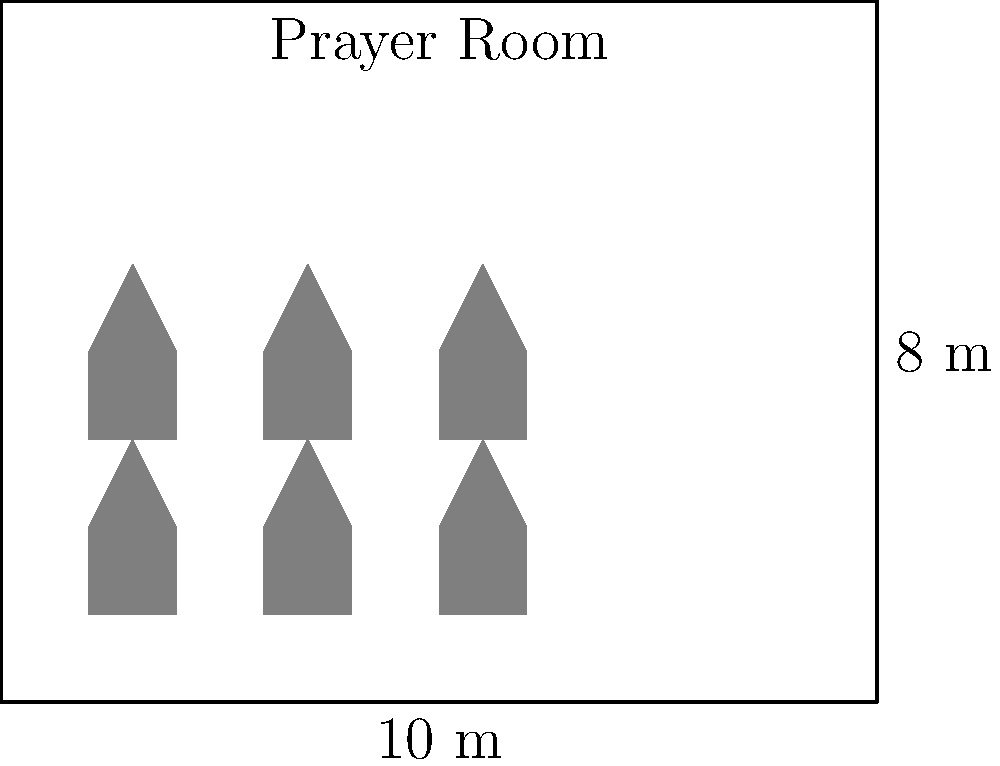The bakery owner has designated a rectangular prayer room measuring 10 meters by 8 meters. Assuming each person requires a prayer space of 1 meter by 0.8 meters, estimate the maximum number of people that can fit in the prayer room while maintaining proper social distancing of 0.5 meters between individuals. Round your answer to the nearest whole number. To solve this problem, let's follow these steps:

1. Calculate the total area of the prayer room:
   $$ \text{Area} = 10\text{ m} \times 8\text{ m} = 80\text{ m}^2 $$

2. Calculate the area needed for each person, including social distancing:
   * Prayer space: $1\text{ m} \times 0.8\text{ m} = 0.8\text{ m}^2$
   * Social distancing area: $(1 + 0.5)\text{ m} \times (0.8 + 0.5)\text{ m} = 1.5\text{ m} \times 1.3\text{ m} = 1.95\text{ m}^2$

3. Calculate the number of people that can fit:
   $$ \text{Number of people} = \frac{\text{Total area}}{\text{Area per person}} = \frac{80\text{ m}^2}{1.95\text{ m}^2} \approx 41.03 $$

4. Round to the nearest whole number:
   $$ 41.03 \approx 41\text{ people} $$

Therefore, the prayer room can accommodate approximately 41 people while maintaining proper social distancing.
Answer: 41 people 